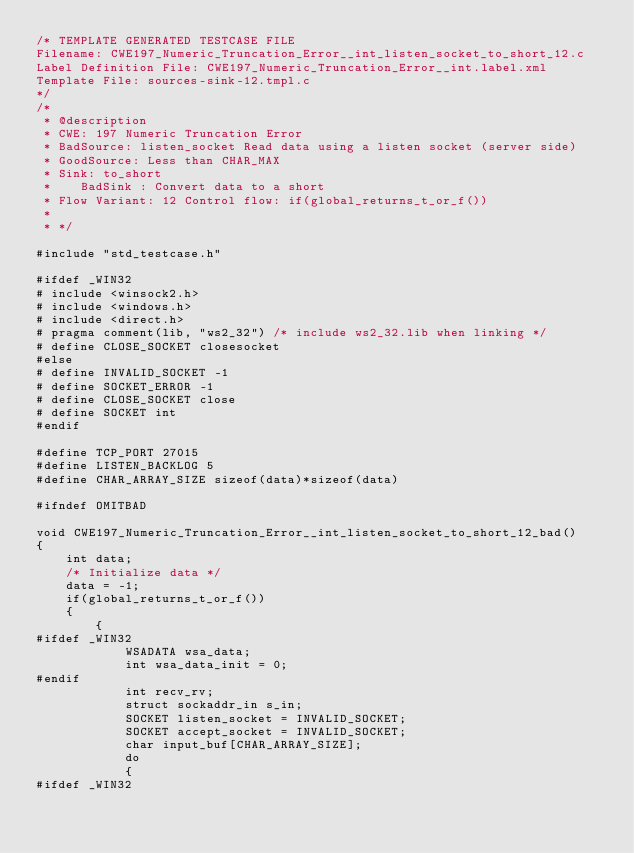Convert code to text. <code><loc_0><loc_0><loc_500><loc_500><_C_>/* TEMPLATE GENERATED TESTCASE FILE
Filename: CWE197_Numeric_Truncation_Error__int_listen_socket_to_short_12.c
Label Definition File: CWE197_Numeric_Truncation_Error__int.label.xml
Template File: sources-sink-12.tmpl.c
*/
/*
 * @description
 * CWE: 197 Numeric Truncation Error
 * BadSource: listen_socket Read data using a listen socket (server side)
 * GoodSource: Less than CHAR_MAX
 * Sink: to_short
 *    BadSink : Convert data to a short
 * Flow Variant: 12 Control flow: if(global_returns_t_or_f())
 *
 * */

#include "std_testcase.h"

#ifdef _WIN32
# include <winsock2.h>
# include <windows.h>
# include <direct.h>
# pragma comment(lib, "ws2_32") /* include ws2_32.lib when linking */
# define CLOSE_SOCKET closesocket
#else
# define INVALID_SOCKET -1
# define SOCKET_ERROR -1
# define CLOSE_SOCKET close
# define SOCKET int
#endif

#define TCP_PORT 27015
#define LISTEN_BACKLOG 5
#define CHAR_ARRAY_SIZE sizeof(data)*sizeof(data)

#ifndef OMITBAD

void CWE197_Numeric_Truncation_Error__int_listen_socket_to_short_12_bad()
{
    int data;
    /* Initialize data */
    data = -1;
    if(global_returns_t_or_f())
    {
        {
#ifdef _WIN32
            WSADATA wsa_data;
            int wsa_data_init = 0;
#endif
            int recv_rv;
            struct sockaddr_in s_in;
            SOCKET listen_socket = INVALID_SOCKET;
            SOCKET accept_socket = INVALID_SOCKET;
            char input_buf[CHAR_ARRAY_SIZE];
            do
            {
#ifdef _WIN32</code> 